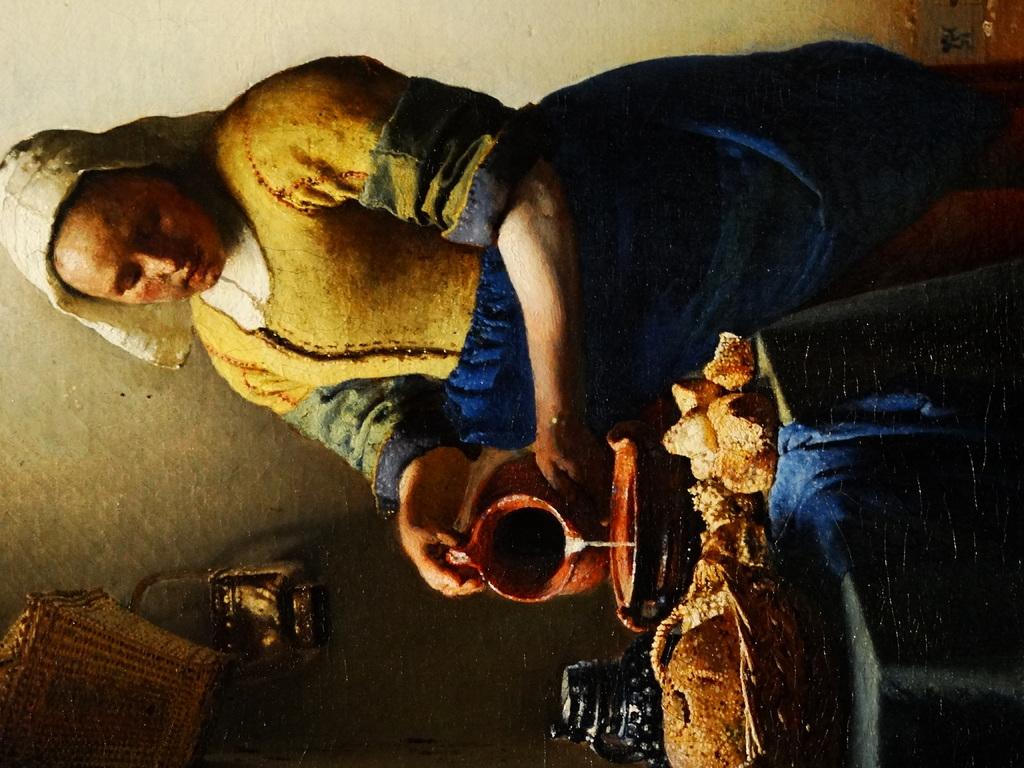Who is the main subject in the image? There is a woman in the image. What is the woman holding in the image? The woman is holding a pot with her hands. What else can be seen in the image besides the woman? There are food items in a basket in the image. How can we describe the style of the image? The image appears to be a painting. What type of scarf is the woman wearing in the image? There is no scarf visible in the image; the woman is holding a pot with her hands. Can you see any hills or volcanoes in the background of the image? The image does not depict any hills or volcanoes; it is a painting of a woman holding a pot and food items in a basket. 